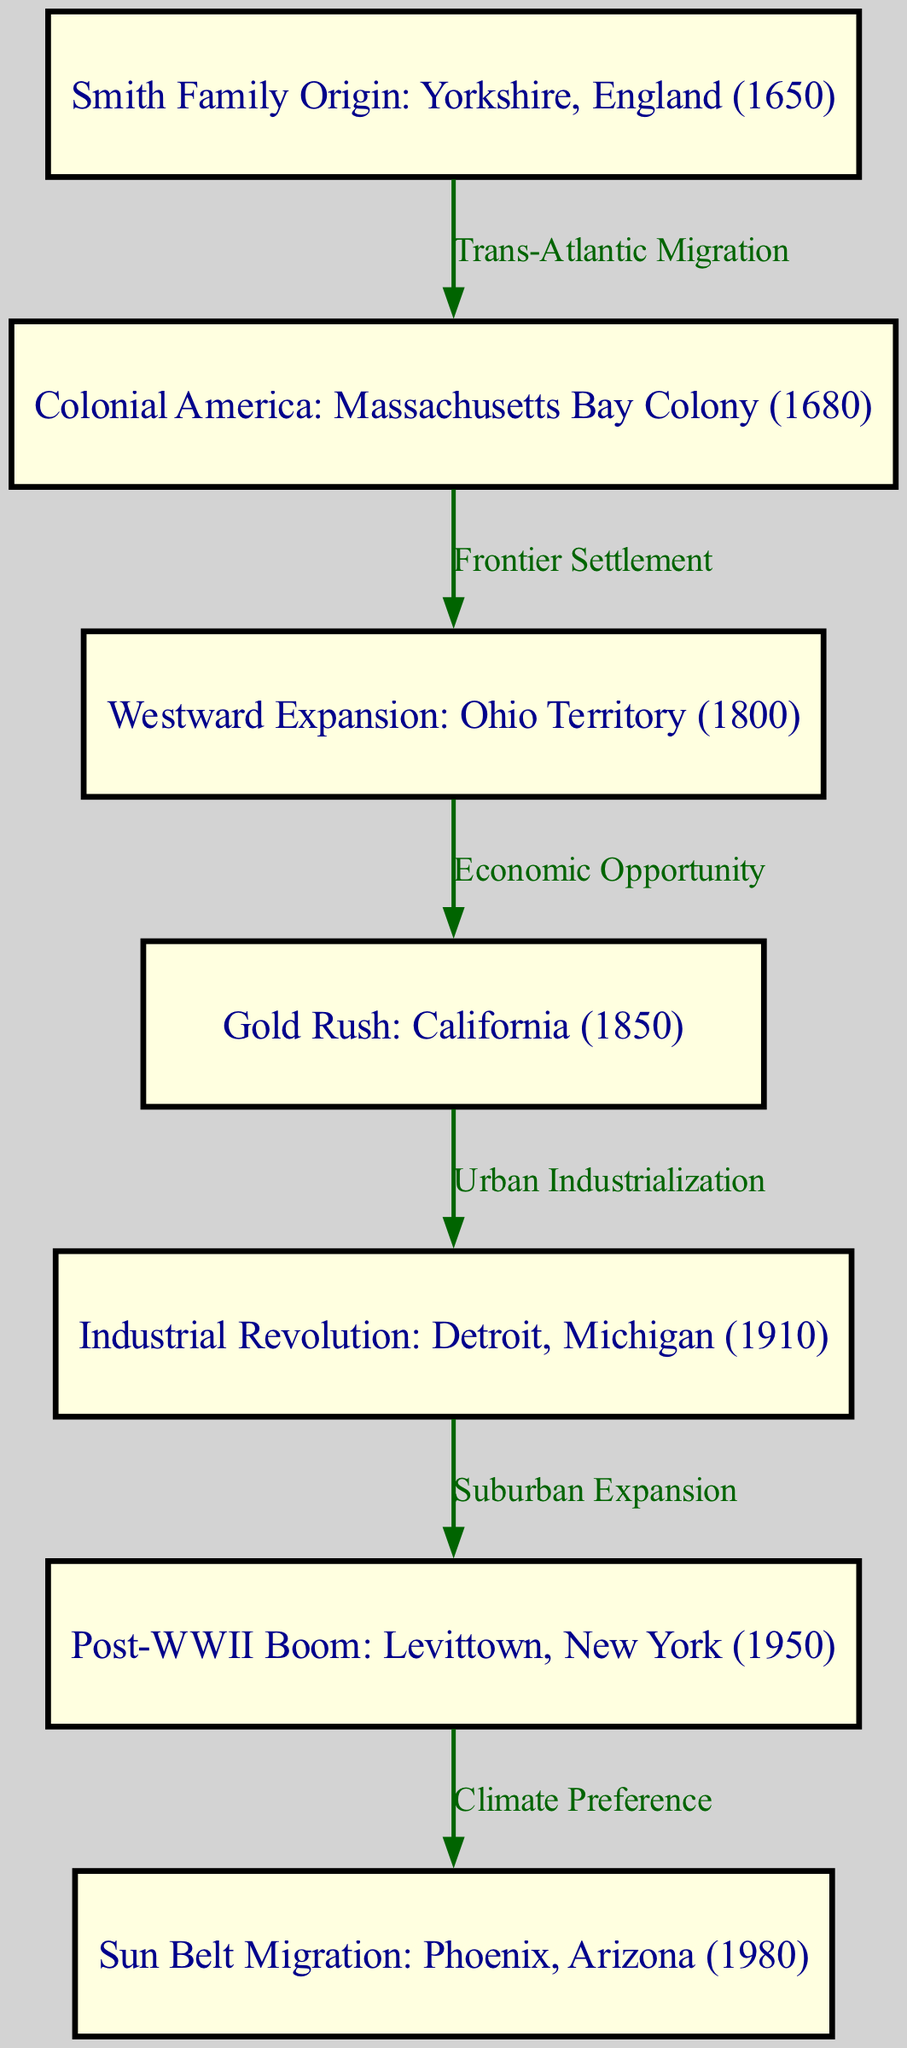What is the origin of the Smith family? The diagram clearly states that the Smith family originated from Yorkshire, England in the year 1650, as depicted in the first node.
Answer: Yorkshire, England (1650) How many migration points are shown in the diagram? By counting the nodes in the diagram, we see there are seven distinct migration points shown.
Answer: 7 What type of migration occurred from Yorkshire, England to Massachusetts Bay Colony? According to the edge label connecting the first node to the second, the migration type is labeled as "Trans-Atlantic Migration."
Answer: Trans-Atlantic Migration Which migration event is represented in the year 1850? The diagram’s fourth node indicates that the migration during the year 1850 is associated with the Gold Rush in California.
Answer: Gold Rush What is the relationship between Detroit, Michigan and Levittown, New York? The edge between the fifth node and the sixth node defines their relationship as "Suburban Expansion," describing the movement from an industrialized city to a suburban region.
Answer: Suburban Expansion Which migration influenced the family's move to Phoenix, Arizona? The label of the edge leading from Levittown, New York to Phoenix, Arizona indicates the reason for this move is "Climate Preference," suggesting that climate was a significant factor behind this migration.
Answer: Climate Preference From which location did the Smith family migrate westward to Ohio Territory? The second node illustrates that the Smith family migrated westward from Massachusetts Bay Colony to Ohio Territory, as indicated by the edge labeled "Frontier Settlement."
Answer: Massachusetts Bay Colony What was a primary reason for the migration to California during the Gold Rush? The diagram specifies that the edge leading to California highlights "Economic Opportunity" as the primary reason for this migration during the Gold Rush period.
Answer: Economic Opportunity 